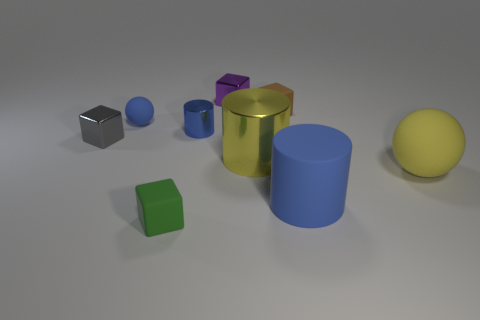What time of day does the lighting in this scene suggest? The soft shadows and even lighting in this image imply an interior setting with artificial lighting rather than natural sunlight, hence it does not strongly suggest any specific time of day. 